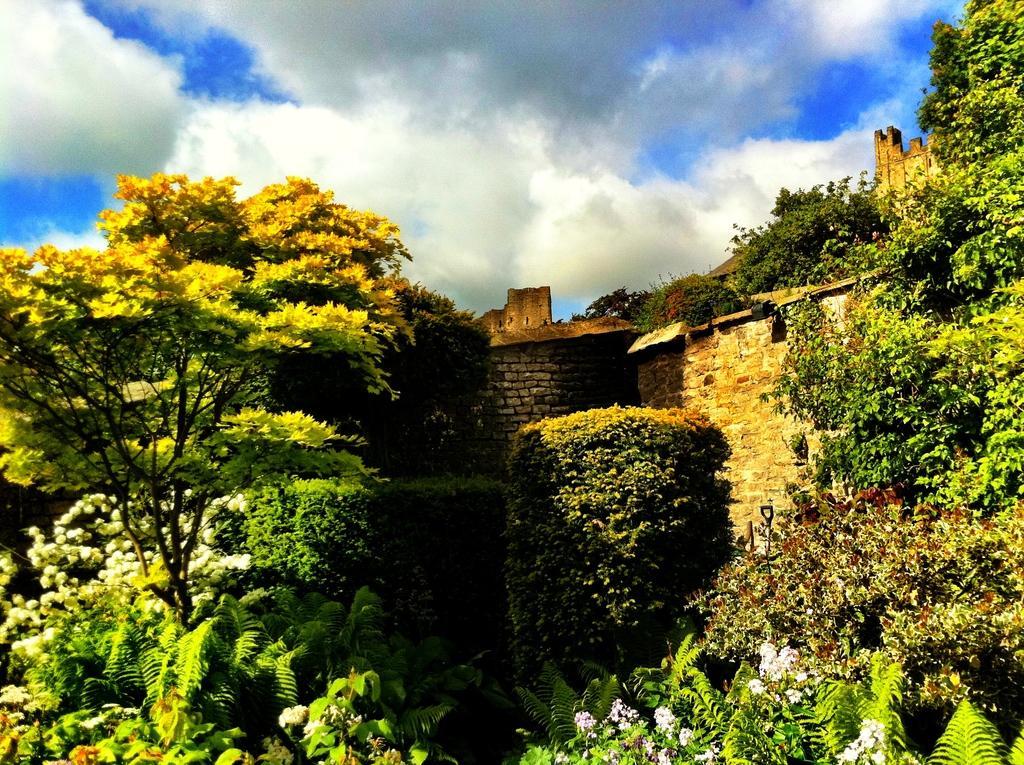Describe this image in one or two sentences. There are trees, stone building and there are clouds in the sky. 